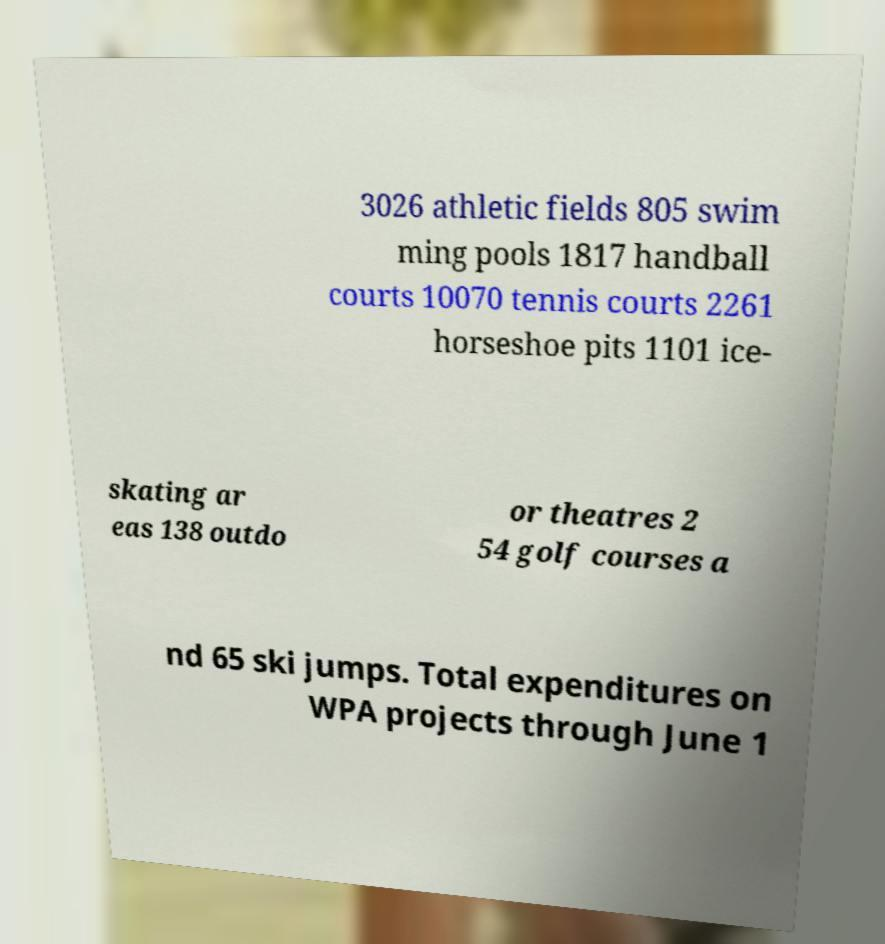Please read and relay the text visible in this image. What does it say? 3026 athletic fields 805 swim ming pools 1817 handball courts 10070 tennis courts 2261 horseshoe pits 1101 ice- skating ar eas 138 outdo or theatres 2 54 golf courses a nd 65 ski jumps. Total expenditures on WPA projects through June 1 